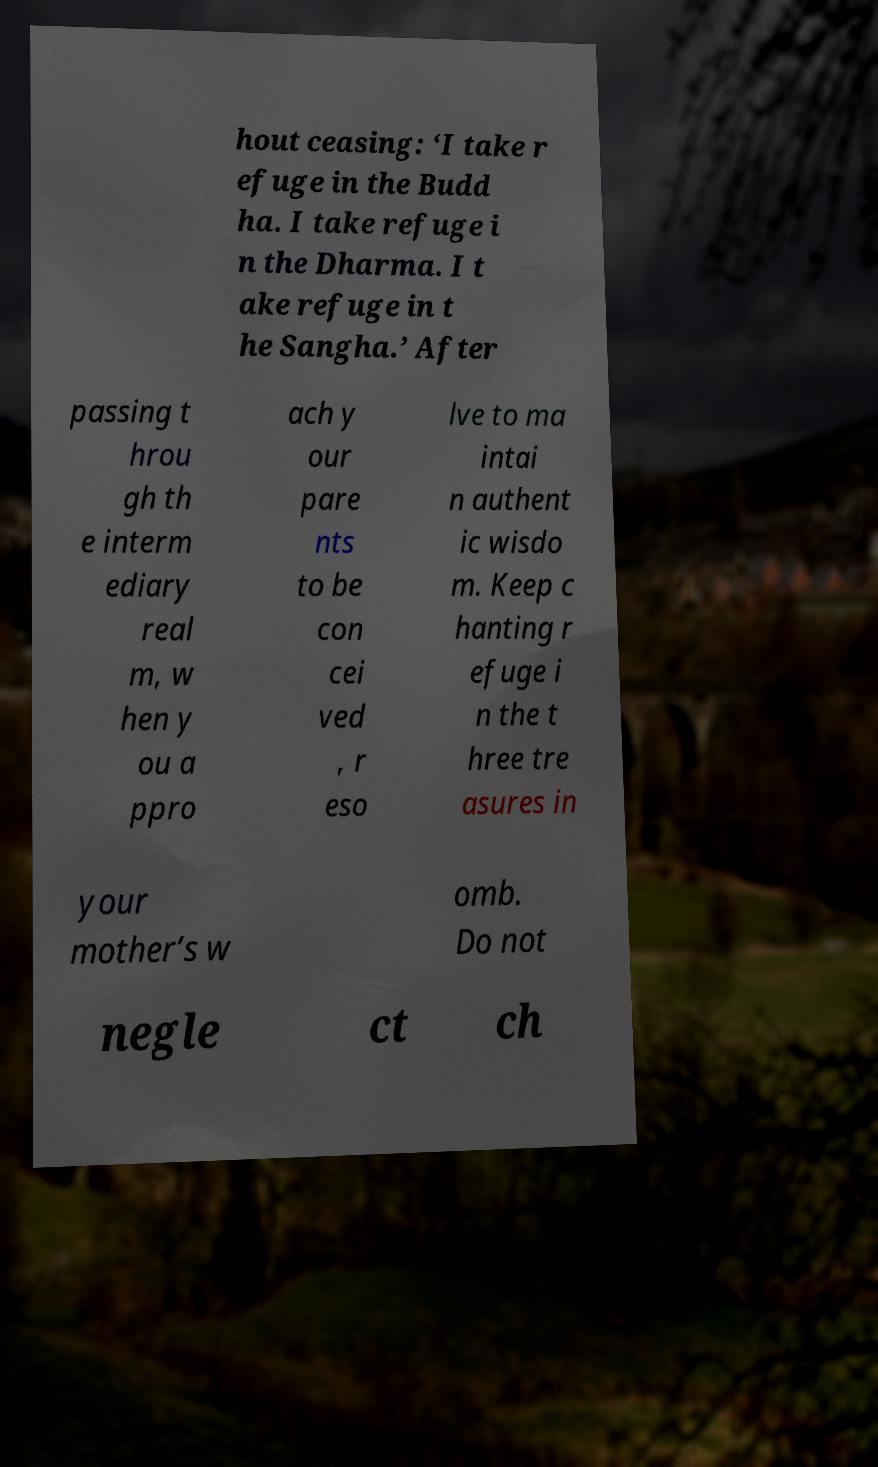Please identify and transcribe the text found in this image. hout ceasing: ‘I take r efuge in the Budd ha. I take refuge i n the Dharma. I t ake refuge in t he Sangha.’ After passing t hrou gh th e interm ediary real m, w hen y ou a ppro ach y our pare nts to be con cei ved , r eso lve to ma intai n authent ic wisdo m. Keep c hanting r efuge i n the t hree tre asures in your mother’s w omb. Do not negle ct ch 